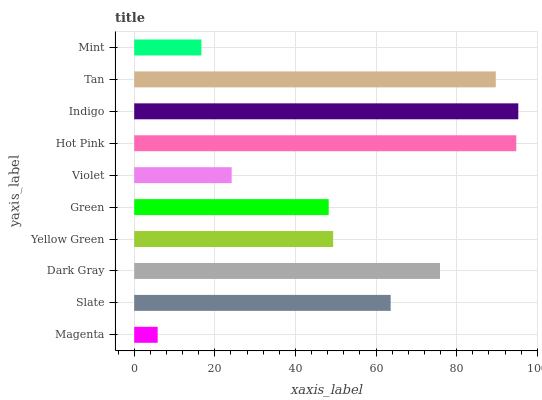Is Magenta the minimum?
Answer yes or no. Yes. Is Indigo the maximum?
Answer yes or no. Yes. Is Slate the minimum?
Answer yes or no. No. Is Slate the maximum?
Answer yes or no. No. Is Slate greater than Magenta?
Answer yes or no. Yes. Is Magenta less than Slate?
Answer yes or no. Yes. Is Magenta greater than Slate?
Answer yes or no. No. Is Slate less than Magenta?
Answer yes or no. No. Is Slate the high median?
Answer yes or no. Yes. Is Yellow Green the low median?
Answer yes or no. Yes. Is Magenta the high median?
Answer yes or no. No. Is Indigo the low median?
Answer yes or no. No. 